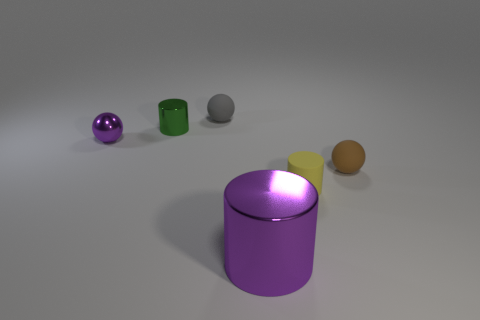Add 2 yellow rubber objects. How many objects exist? 8 Add 3 small balls. How many small balls are left? 6 Add 1 cylinders. How many cylinders exist? 4 Subtract 1 green cylinders. How many objects are left? 5 Subtract all brown matte cubes. Subtract all small green objects. How many objects are left? 5 